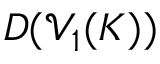Convert formula to latex. <formula><loc_0><loc_0><loc_500><loc_500>D ( \mathcal { V } _ { 1 } ( K ) )</formula> 